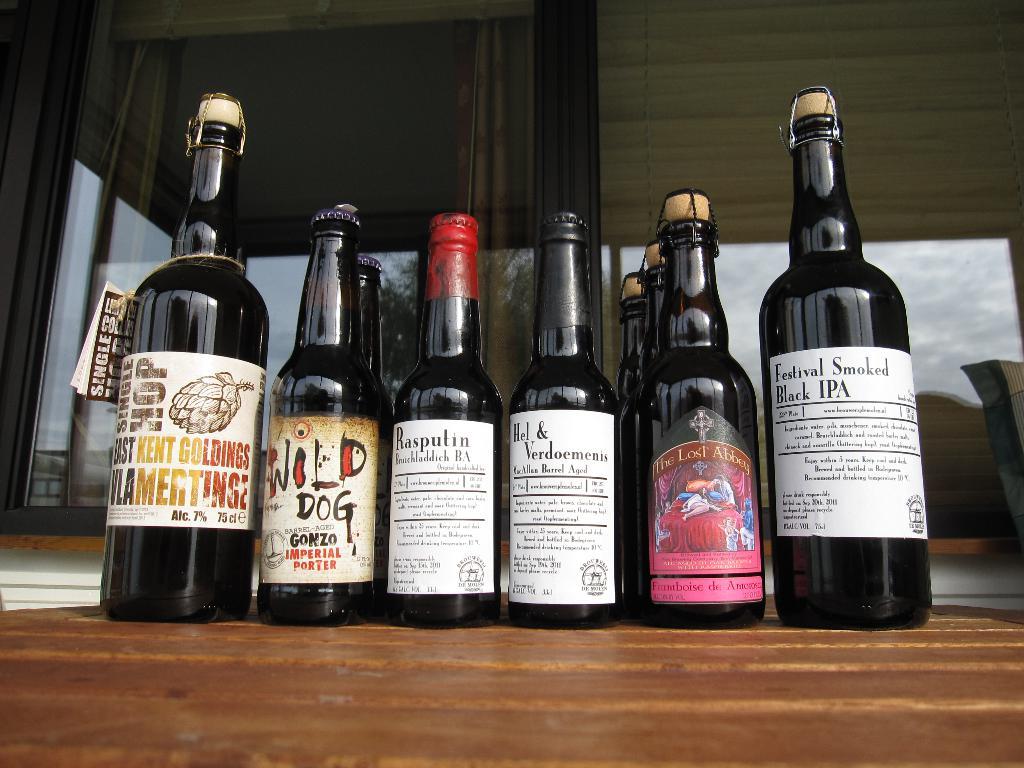What animal is part of the brand of the second bottle from the left?
Offer a terse response. Dog. What is the first one called?
Make the answer very short. Festival standard. 